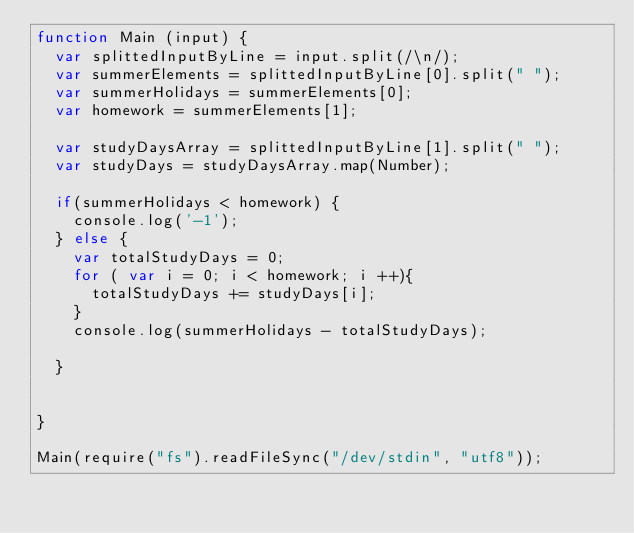<code> <loc_0><loc_0><loc_500><loc_500><_JavaScript_>function Main (input) {
  var splittedInputByLine = input.split(/\n/);
  var summerElements = splittedInputByLine[0].split(" ");
  var summerHolidays = summerElements[0];
  var homework = summerElements[1];
  
  var studyDaysArray = splittedInputByLine[1].split(" ");
  var studyDays = studyDaysArray.map(Number);
      
  if(summerHolidays < homework) {
    console.log('-1');
  } else {
    var totalStudyDays = 0;
    for ( var i = 0; i < homework; i ++){
      totalStudyDays += studyDays[i];
    }
    console.log(summerHolidays - totalStudyDays);
    
  }
  
	
}

Main(require("fs").readFileSync("/dev/stdin", "utf8"));
</code> 